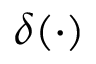Convert formula to latex. <formula><loc_0><loc_0><loc_500><loc_500>\delta ( \cdot )</formula> 